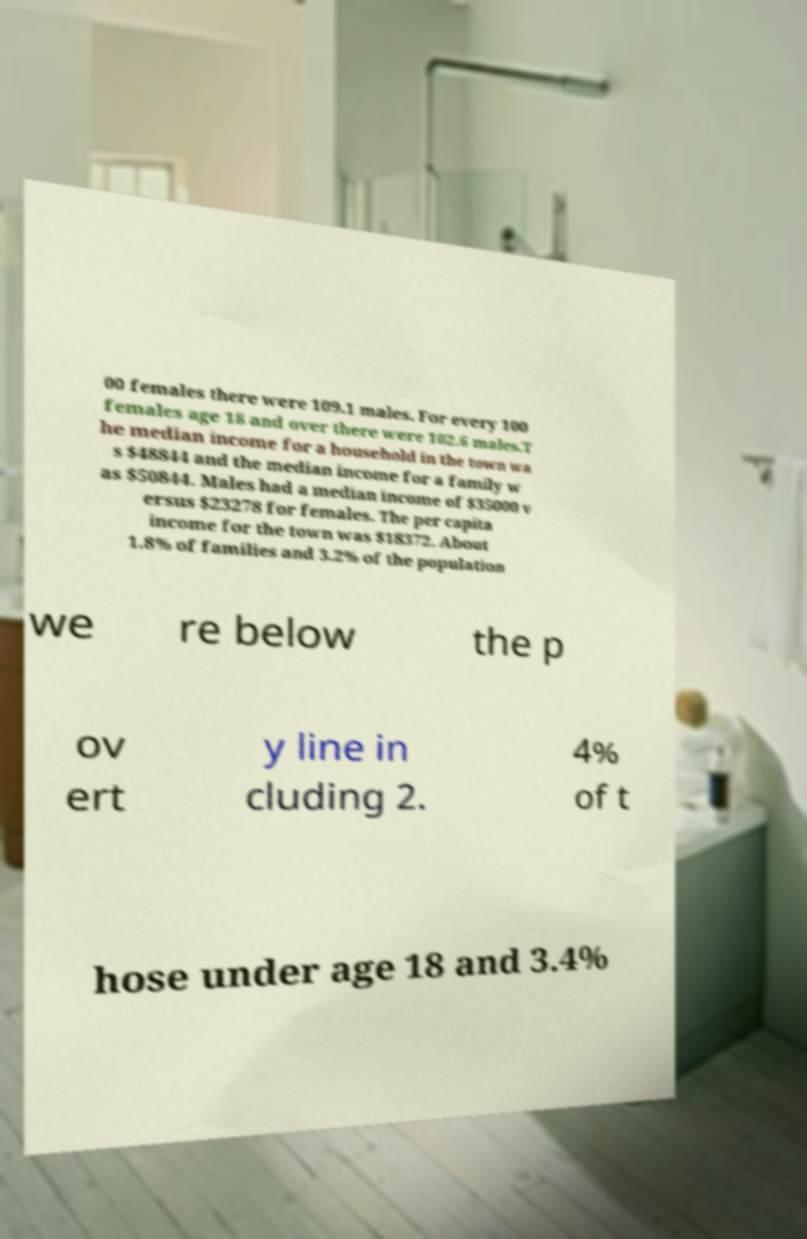Can you accurately transcribe the text from the provided image for me? 00 females there were 109.1 males. For every 100 females age 18 and over there were 102.6 males.T he median income for a household in the town wa s $48844 and the median income for a family w as $50844. Males had a median income of $35000 v ersus $23278 for females. The per capita income for the town was $18372. About 1.8% of families and 3.2% of the population we re below the p ov ert y line in cluding 2. 4% of t hose under age 18 and 3.4% 